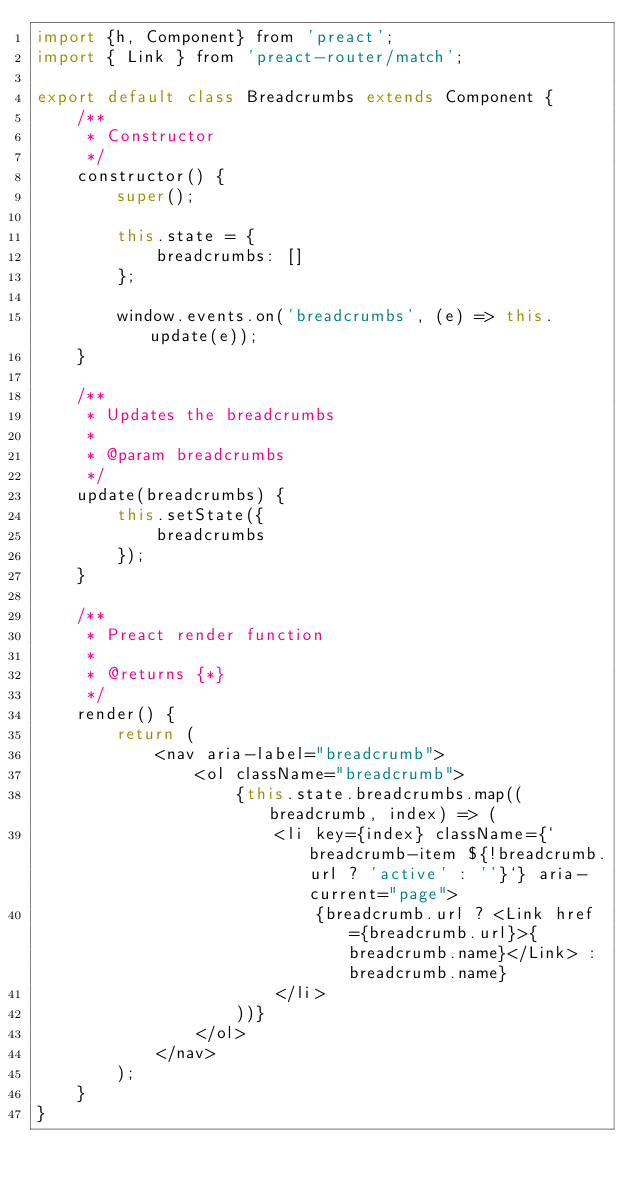Convert code to text. <code><loc_0><loc_0><loc_500><loc_500><_JavaScript_>import {h, Component} from 'preact';
import { Link } from 'preact-router/match';

export default class Breadcrumbs extends Component {
    /**
     * Constructor
     */
    constructor() {
        super();

        this.state = {
            breadcrumbs: []
        };

        window.events.on('breadcrumbs', (e) => this.update(e));
    }

    /**
     * Updates the breadcrumbs
     *
     * @param breadcrumbs
     */
    update(breadcrumbs) {
        this.setState({
            breadcrumbs
        });
    }

    /**
     * Preact render function
     *
     * @returns {*}
     */
    render() {
        return (
            <nav aria-label="breadcrumb">
                <ol className="breadcrumb">
                    {this.state.breadcrumbs.map((breadcrumb, index) => (
                        <li key={index} className={`breadcrumb-item ${!breadcrumb.url ? 'active' : ''}`} aria-current="page">
                            {breadcrumb.url ? <Link href={breadcrumb.url}>{breadcrumb.name}</Link> : breadcrumb.name}
                        </li>
                    ))}
                </ol>
            </nav>
        );
    }
}
</code> 